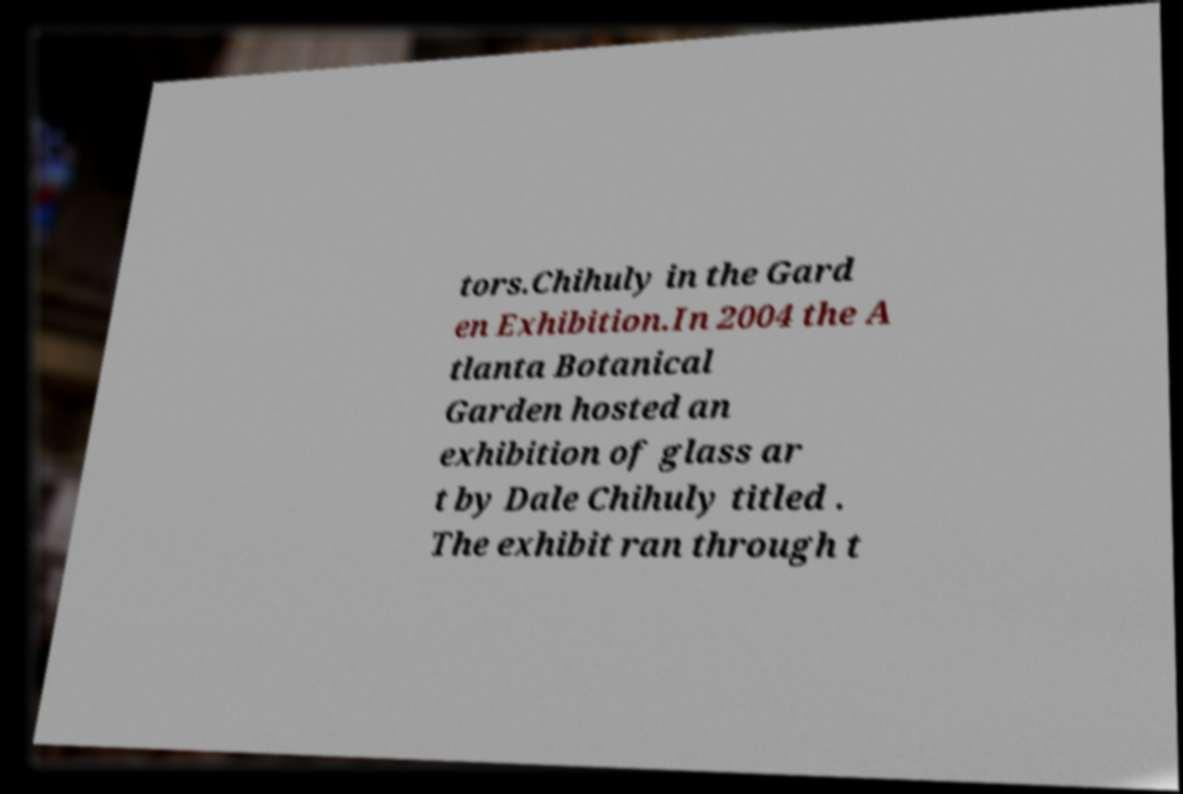Could you extract and type out the text from this image? tors.Chihuly in the Gard en Exhibition.In 2004 the A tlanta Botanical Garden hosted an exhibition of glass ar t by Dale Chihuly titled . The exhibit ran through t 